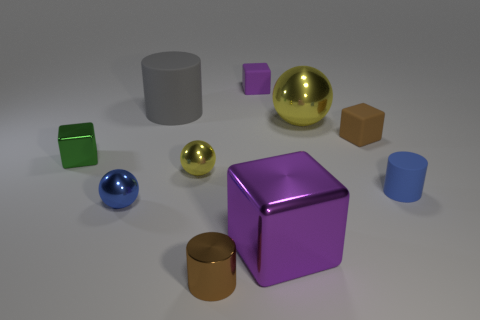Subtract 1 cubes. How many cubes are left? 3 Subtract all blocks. How many objects are left? 6 Subtract 0 red cylinders. How many objects are left? 10 Subtract all tiny cylinders. Subtract all tiny matte cylinders. How many objects are left? 7 Add 4 tiny blue balls. How many tiny blue balls are left? 5 Add 7 tiny gray shiny cylinders. How many tiny gray shiny cylinders exist? 7 